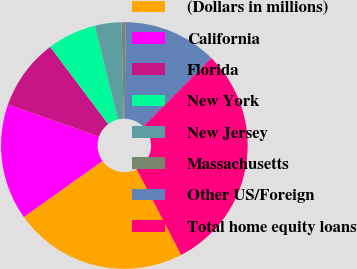<chart> <loc_0><loc_0><loc_500><loc_500><pie_chart><fcel>(Dollars in millions)<fcel>California<fcel>Florida<fcel>New York<fcel>New Jersey<fcel>Massachusetts<fcel>Other US/Foreign<fcel>Total home equity loans<nl><fcel>22.78%<fcel>15.23%<fcel>9.35%<fcel>6.42%<fcel>3.48%<fcel>0.54%<fcel>12.29%<fcel>29.91%<nl></chart> 